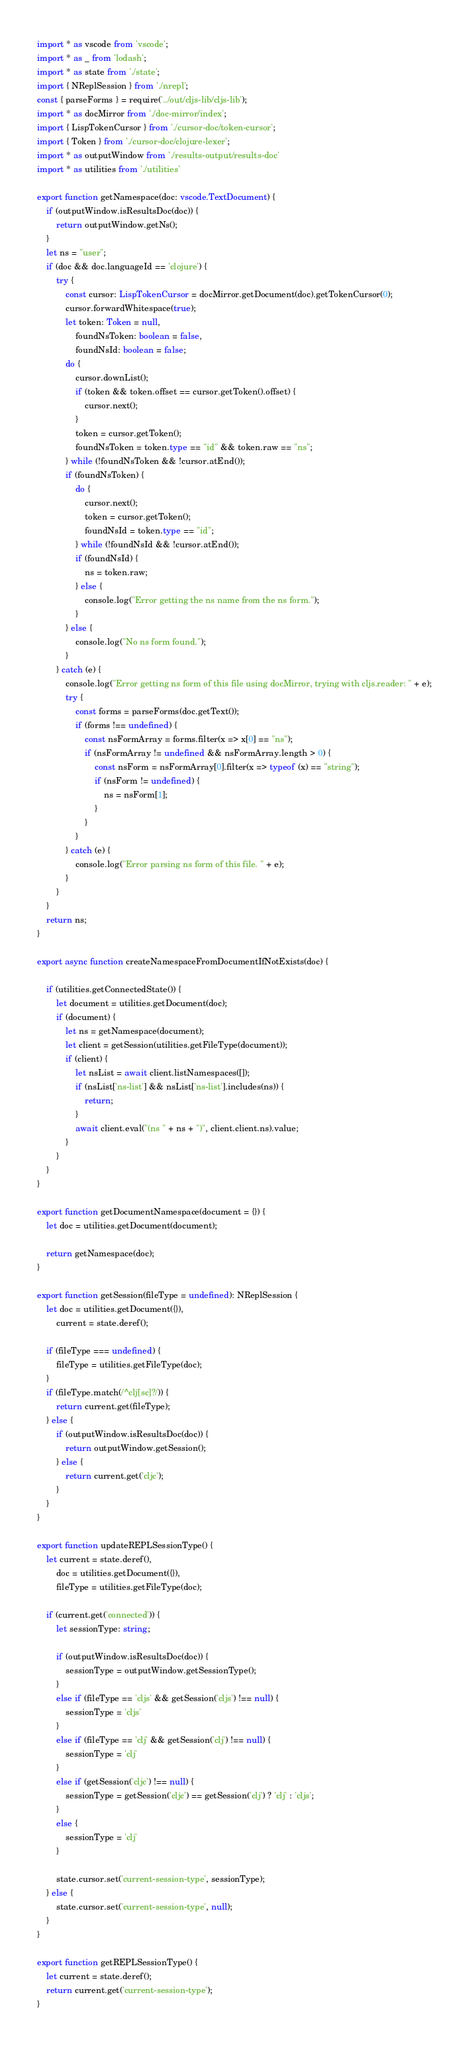Convert code to text. <code><loc_0><loc_0><loc_500><loc_500><_TypeScript_>import * as vscode from 'vscode';
import * as _ from 'lodash';
import * as state from './state';
import { NReplSession } from './nrepl';
const { parseForms } = require('../out/cljs-lib/cljs-lib');
import * as docMirror from './doc-mirror/index';
import { LispTokenCursor } from './cursor-doc/token-cursor';
import { Token } from './cursor-doc/clojure-lexer';
import * as outputWindow from './results-output/results-doc'
import * as utilities from './utilities'

export function getNamespace(doc: vscode.TextDocument) {
    if (outputWindow.isResultsDoc(doc)) {
        return outputWindow.getNs();
    }
    let ns = "user";
    if (doc && doc.languageId == 'clojure') {
        try {
            const cursor: LispTokenCursor = docMirror.getDocument(doc).getTokenCursor(0);
            cursor.forwardWhitespace(true);
            let token: Token = null,
                foundNsToken: boolean = false,
                foundNsId: boolean = false;
            do {
                cursor.downList();
                if (token && token.offset == cursor.getToken().offset) {
                    cursor.next();
                }
                token = cursor.getToken();
                foundNsToken = token.type == "id" && token.raw == "ns";
            } while (!foundNsToken && !cursor.atEnd());
            if (foundNsToken) {
                do {
                    cursor.next();
                    token = cursor.getToken();
                    foundNsId = token.type == "id";
                } while (!foundNsId && !cursor.atEnd());
                if (foundNsId) {
                    ns = token.raw;
                } else {
                    console.log("Error getting the ns name from the ns form.");
                }
            } else {
                console.log("No ns form found.");
            }
        } catch (e) {
            console.log("Error getting ns form of this file using docMirror, trying with cljs.reader: " + e);
            try {
                const forms = parseForms(doc.getText());
                if (forms !== undefined) {
                    const nsFormArray = forms.filter(x => x[0] == "ns");
                    if (nsFormArray != undefined && nsFormArray.length > 0) {
                        const nsForm = nsFormArray[0].filter(x => typeof (x) == "string");
                        if (nsForm != undefined) {
                            ns = nsForm[1];
                        }
                    }
                }
            } catch (e) {
                console.log("Error parsing ns form of this file. " + e);
            }
        }
    }
    return ns;
}

export async function createNamespaceFromDocumentIfNotExists(doc) {

    if (utilities.getConnectedState()) {
        let document = utilities.getDocument(doc);
        if (document) {
            let ns = getNamespace(document);
            let client = getSession(utilities.getFileType(document));
            if (client) {
                let nsList = await client.listNamespaces([]);
                if (nsList['ns-list'] && nsList['ns-list'].includes(ns)) {
                    return;
                }
                await client.eval("(ns " + ns + ")", client.client.ns).value;
            }
        }
    }
}

export function getDocumentNamespace(document = {}) {
    let doc = utilities.getDocument(document);

    return getNamespace(doc);
}

export function getSession(fileType = undefined): NReplSession {
    let doc = utilities.getDocument({}),
        current = state.deref();

    if (fileType === undefined) {
        fileType = utilities.getFileType(doc);
    }
    if (fileType.match(/^clj[sc]?/)) {
        return current.get(fileType);
    } else {
        if (outputWindow.isResultsDoc(doc)) {
            return outputWindow.getSession();
        } else {
            return current.get('cljc');
        }
    }
}

export function updateREPLSessionType() {
    let current = state.deref(),
        doc = utilities.getDocument({}),
        fileType = utilities.getFileType(doc);

    if (current.get('connected')) {
        let sessionType: string;

        if (outputWindow.isResultsDoc(doc)) {
            sessionType = outputWindow.getSessionType();
        }
        else if (fileType == 'cljs' && getSession('cljs') !== null) {
            sessionType = 'cljs'
        }
        else if (fileType == 'clj' && getSession('clj') !== null) {
            sessionType = 'clj'
        }
        else if (getSession('cljc') !== null) {
            sessionType = getSession('cljc') == getSession('clj') ? 'clj' : 'cljs';
        }
        else {
            sessionType = 'clj'
        }

        state.cursor.set('current-session-type', sessionType);
    } else {
        state.cursor.set('current-session-type', null);
    }
}

export function getREPLSessionType() {
    let current = state.deref();
    return current.get('current-session-type');
}
</code> 